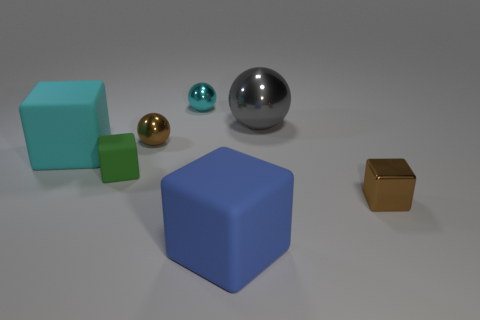Subtract all cyan cubes. How many cubes are left? 3 Subtract 1 cubes. How many cubes are left? 3 Subtract all green cubes. How many cubes are left? 3 Add 1 gray things. How many objects exist? 8 Subtract all gray cubes. Subtract all cyan cylinders. How many cubes are left? 4 Subtract all balls. How many objects are left? 4 Add 5 gray things. How many gray things are left? 6 Add 7 cyan blocks. How many cyan blocks exist? 8 Subtract 1 brown spheres. How many objects are left? 6 Subtract all green objects. Subtract all brown blocks. How many objects are left? 5 